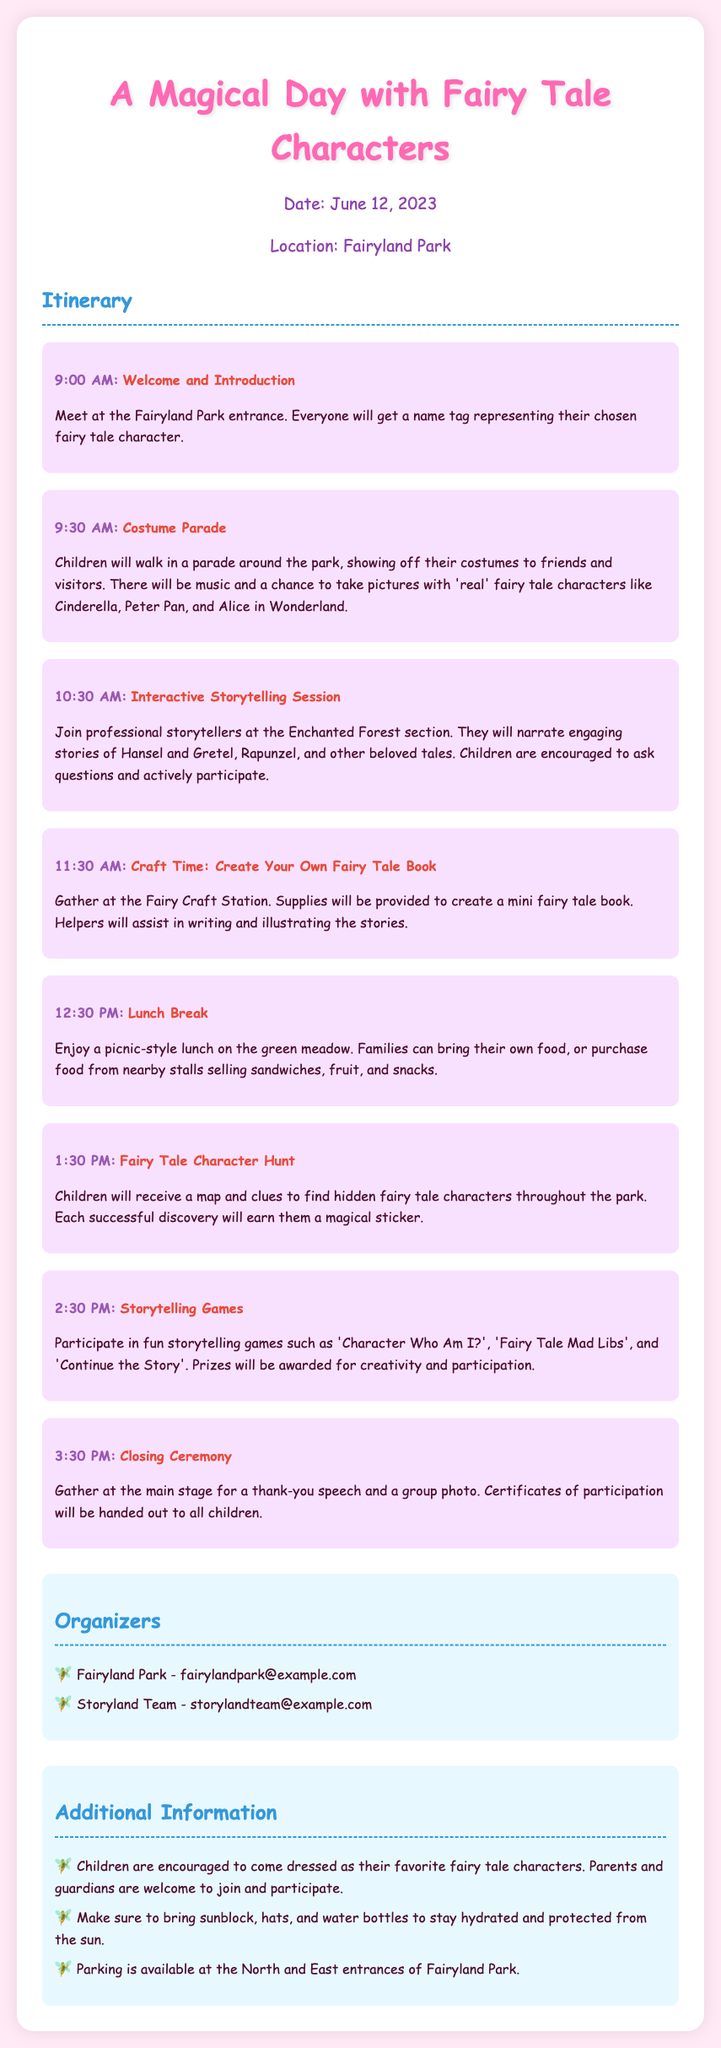What is the date of the event? The date of the event is stated in the "date-location" section of the document.
Answer: June 12, 2023 Where is the event taking place? The location of the event is also included in the "date-location" section.
Answer: Fairyland Park What time does the costume parade start? The starting time for the costume parade is presented in the itinerary list.
Answer: 9:30 AM Which fairy tale characters can children meet during the costume parade? The document mentions specific characters children can meet during the parade.
Answer: Cinderella, Peter Pan, and Alice in Wonderland What activity involves creating a mini book? The specific activity that involves creating a mini book is found in the itinerary.
Answer: Craft Time: Create Your Own Fairy Tale Book How long is the lunch break? The itinerary provides details on the duration of the lunch break.
Answer: 1 hour What will children earn during the Fairy Tale Character Hunt? The document specifies what children receive upon successfully finding characters.
Answer: A magical sticker What type of games will be played at 2:30 PM? The event schedule outlines the type of activities that occur at this time.
Answer: Storytelling games What will children receive at the Closing Ceremony? The details of the closing ceremony include what is given to children.
Answer: Certificates of participation 